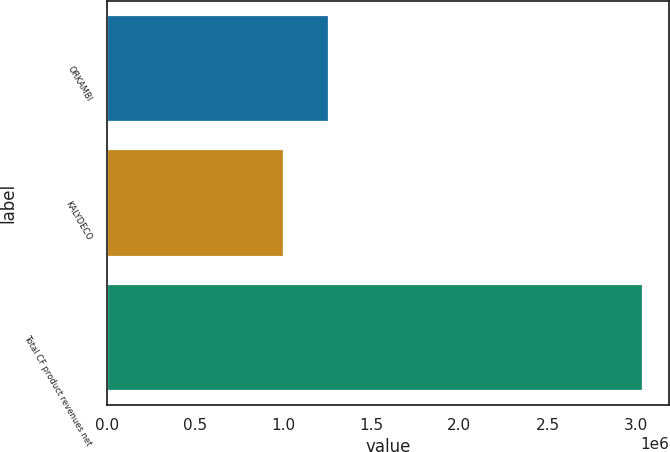Convert chart. <chart><loc_0><loc_0><loc_500><loc_500><bar_chart><fcel>ORKAMBI<fcel>KALYDECO<fcel>Total CF product revenues net<nl><fcel>1.26217e+06<fcel>1.0075e+06<fcel>3.03832e+06<nl></chart> 